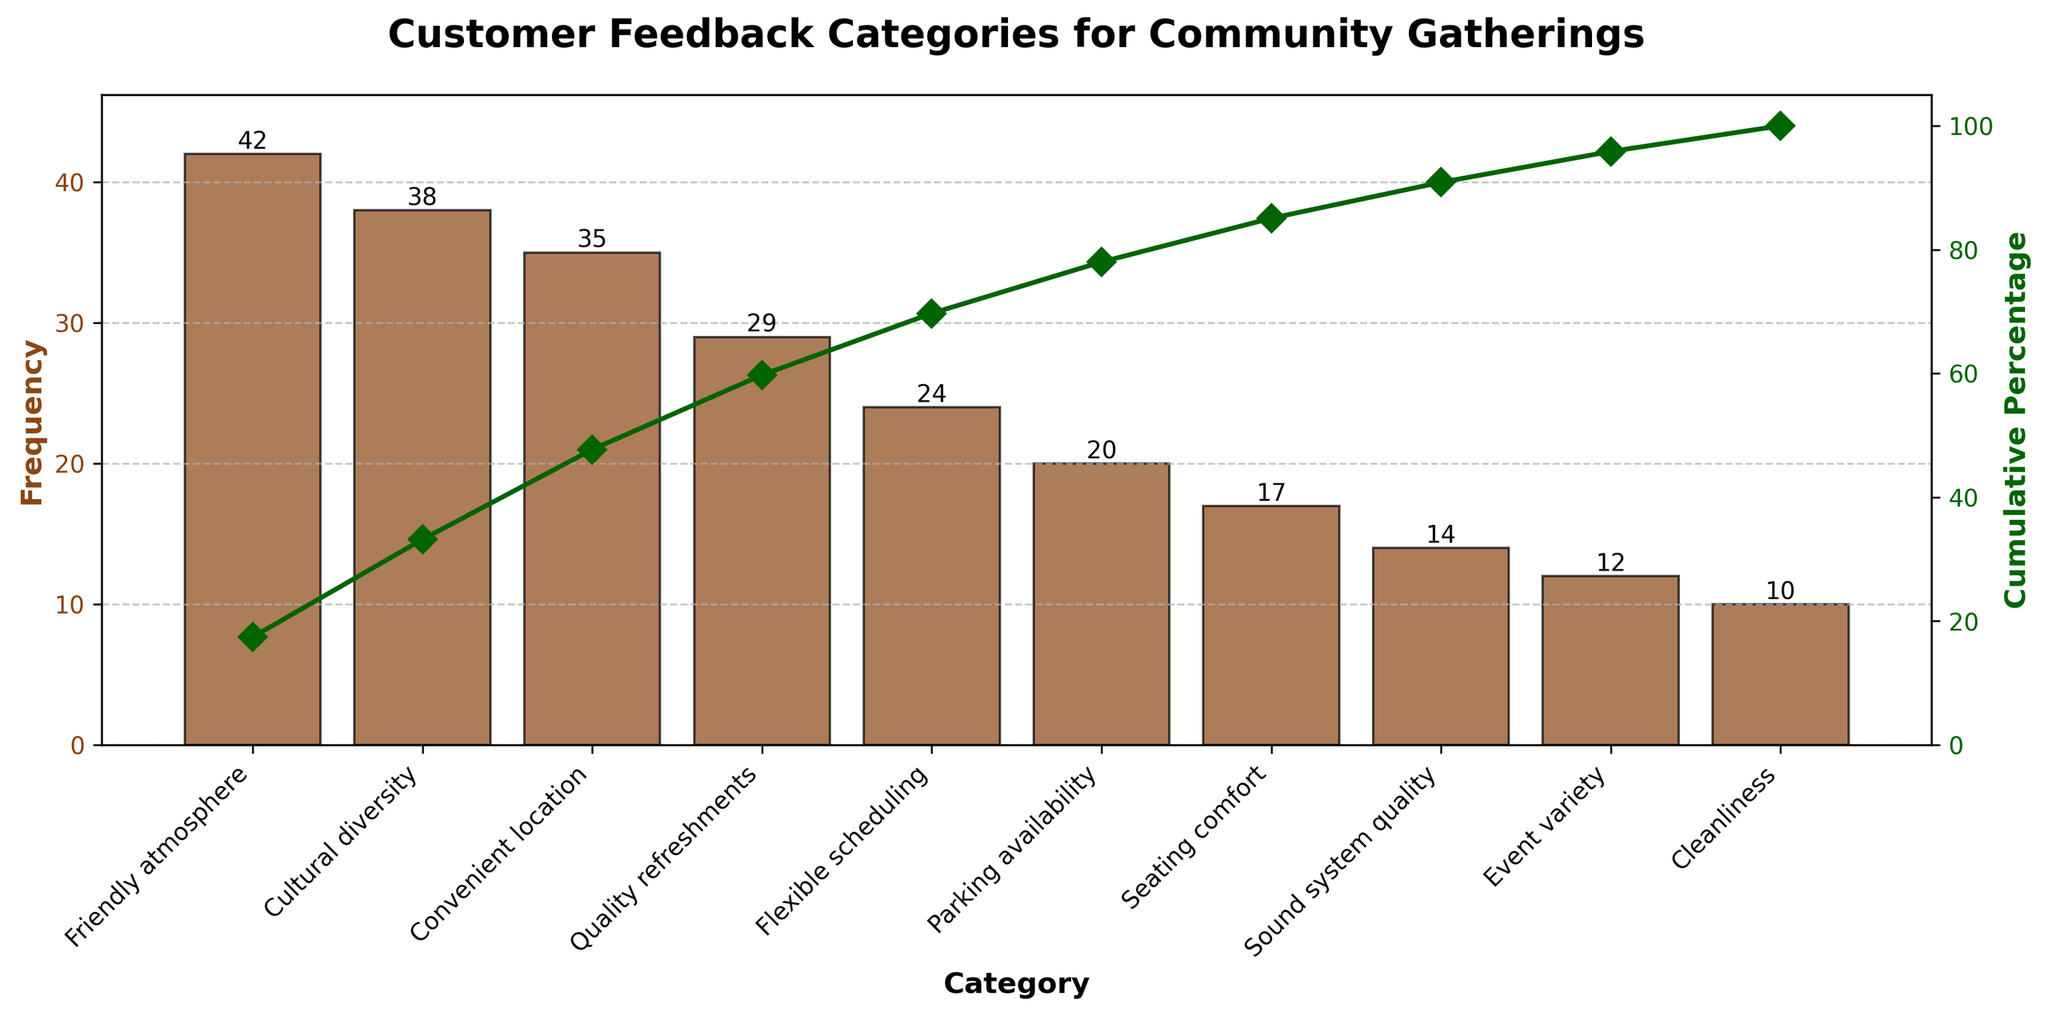What is the title of the chart? The title of a chart is usually placed at the top and is meant to provide a brief and clear summary of what the chart is about. Here, the title is visible at the top of the figure.
Answer: Customer Feedback Categories for Community Gatherings Which feedback category has the highest frequency? The feedback category with the highest frequency is represented by the tallest bar on the Pareto chart. It can be identified by reading the label under the tallest bar.
Answer: Friendly atmosphere What is the cumulative percentage of the top three feedback categories? The cumulative percentage is visually represented by the line on the chart. To find the cumulative percentage of the top three categories (Friendly atmosphere, Cultural diversity, Convenient location), look at the cumulative percentage value at the third category on the x-axis.
Answer: 68.5% How many feedback categories have a frequency of 20 or more? To find this, count the bars that have a height representing frequencies of 20 or more. From the chart, we count the categories: Friendly atmosphere, Cultural diversity, Convenient location, Quality refreshments, and Flexible scheduling.
Answer: 5 What is the total frequency of feedback for the bottom five categories? Sum the frequencies of the bottom five categories, which are Parking availability (20), Seating comfort (17), Sound system quality (14), Event variety (12), and Cleanliness (10). Add these values together.
Answer: 20 + 17 + 14 + 12 + 10 = 73 Which category has the lowest frequency and what is its value? The bar with the shortest height on the chart represents the category with the lowest frequency. By identifying this bar and reading its label, we find the category and its frequency value.
Answer: Cleanliness, 10 Is the frequency of Cultural diversity higher than Quality refreshments? Compare the heights of the bars corresponding to these two categories. Cultural diversity has a taller bar than Quality refreshments.
Answer: Yes What is the cumulative percentage of the category Event variety? Find the position of the Event variety on the x-axis and then look up the cumulative percentage indicated by the line passing through this category.
Answer: 96.5% How does the frequency of Flexible scheduling compare to Seating comfort? Compare the heights of the bars for Flexible scheduling and Seating comfort. The category Flexible scheduling has a higher bar compared to Seating comfort.
Answer: Flexible scheduling has a higher frequency Did more people comment on Sound system quality or Parking availability? Compare the bar heights for Sound system quality and Parking availability. The Parking availability bar is higher than the Sound system quality bar.
Answer: Parking availability 